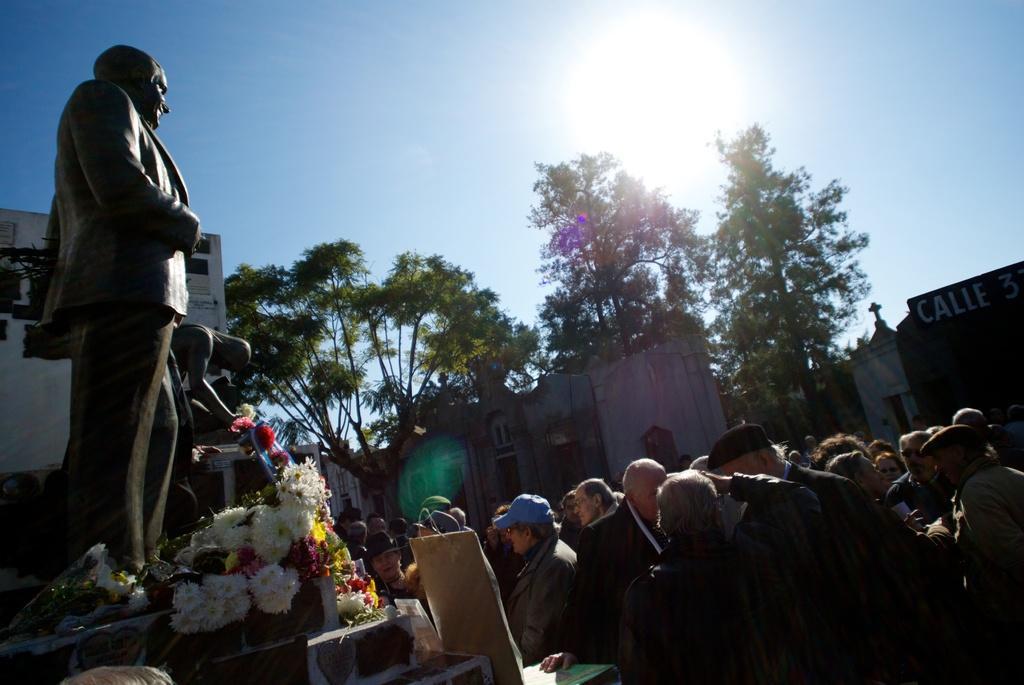Can you describe this image briefly? In this image I can see the group of people are standing. I can see few statues, trees, buildings, windows, different color flowers and few objects. The sky is in blue and white color. 